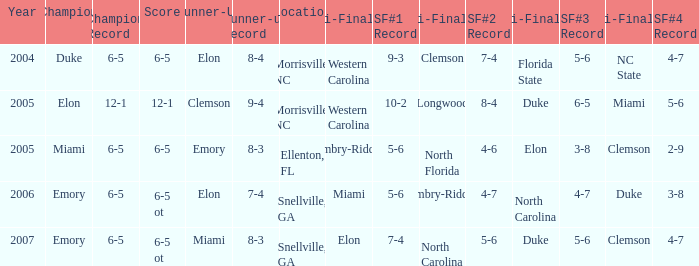When Embry-Riddle made it to the first semi finalist slot, list all the runners up. Emory. 